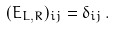<formula> <loc_0><loc_0><loc_500><loc_500>( { E } _ { L , R } ) _ { i j } = \delta _ { i j } \, .</formula> 